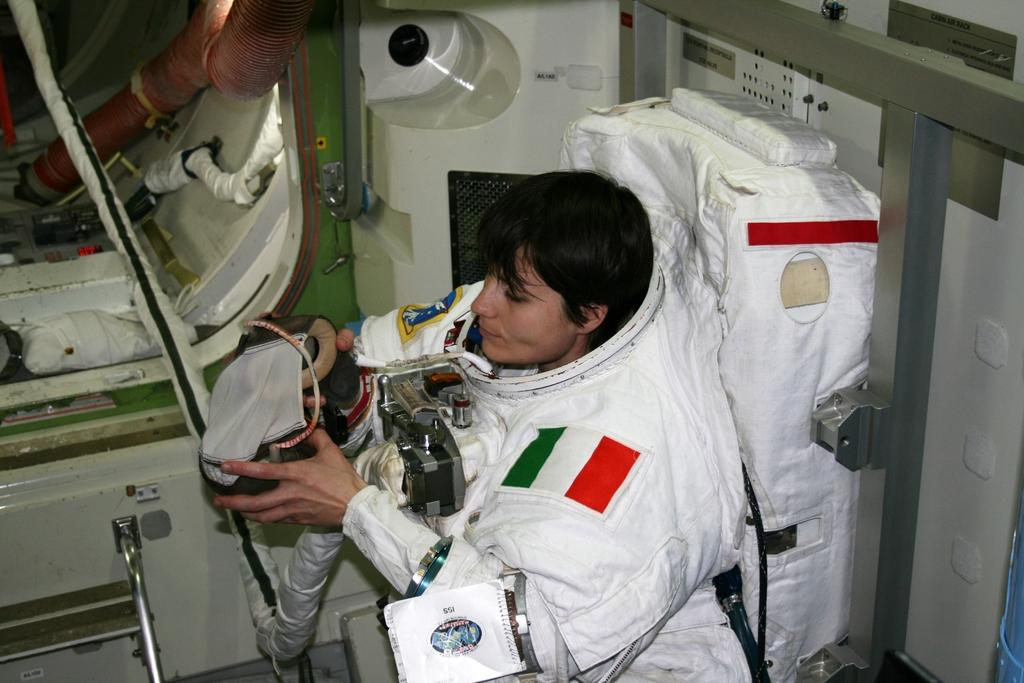Who is the main subject in the foreground of the image? There is a woman in the foreground of the image. What is the woman wearing in the image? The woman is wearing a space suit in the image. What is the woman holding in her hand in the image? The woman is holding a machine in her hand in the image. What can be seen in the background of the image? There are pipes and a door of a spaceship visible in the background of the image. Can you see the woman's toes in the image? There is no visible indication of the woman's toes in the image, as she is wearing a space suit that covers her feet. 